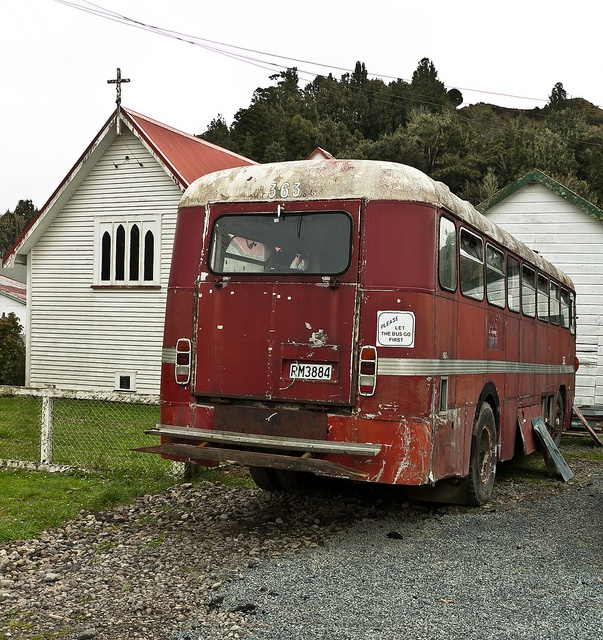Describe the objects in this image and their specific colors. I can see bus in white, maroon, black, gray, and darkgray tones in this image. 